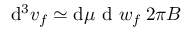Convert formula to latex. <formula><loc_0><loc_0><loc_500><loc_500>d ^ { 3 } v _ { f } \simeq d \mu d w _ { f } \, 2 \pi B</formula> 